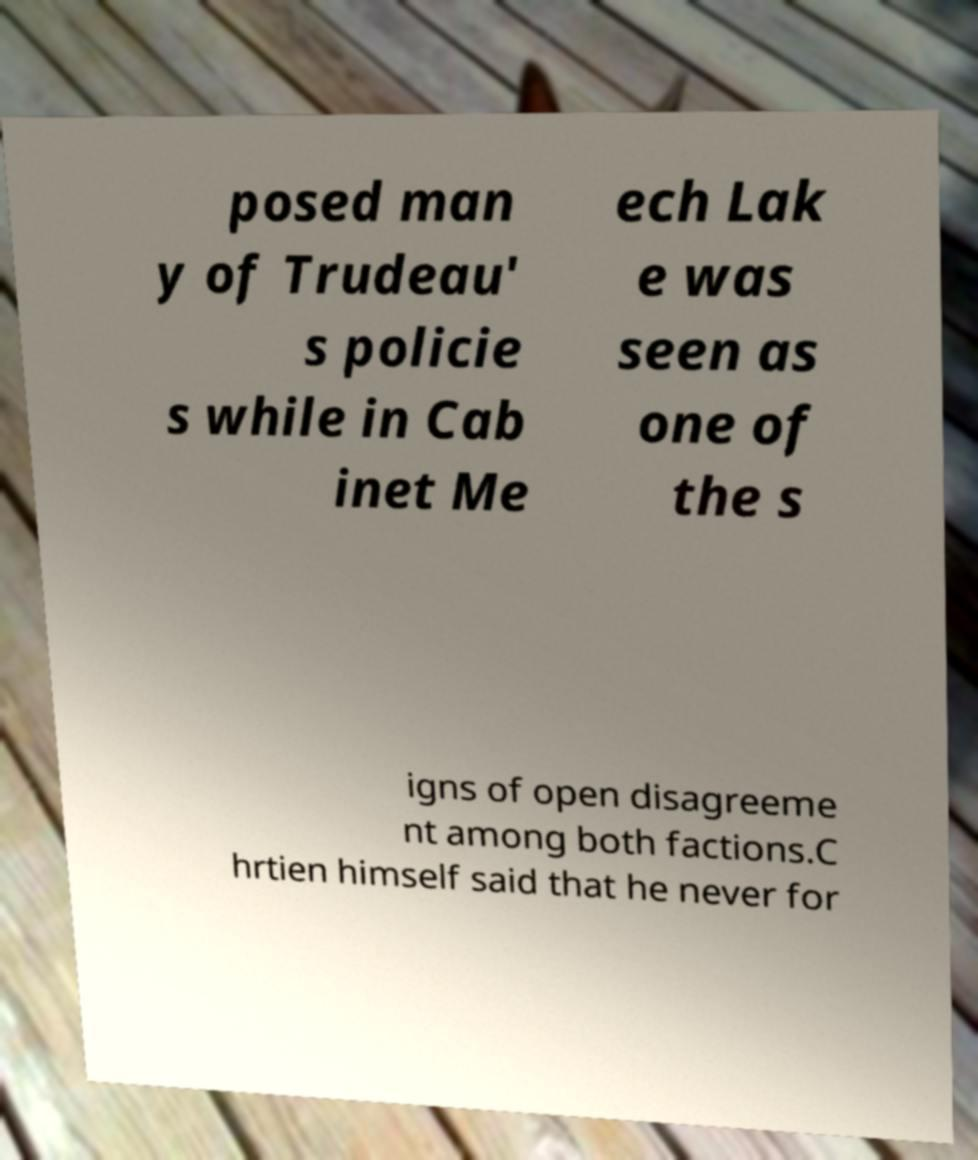Could you assist in decoding the text presented in this image and type it out clearly? posed man y of Trudeau' s policie s while in Cab inet Me ech Lak e was seen as one of the s igns of open disagreeme nt among both factions.C hrtien himself said that he never for 